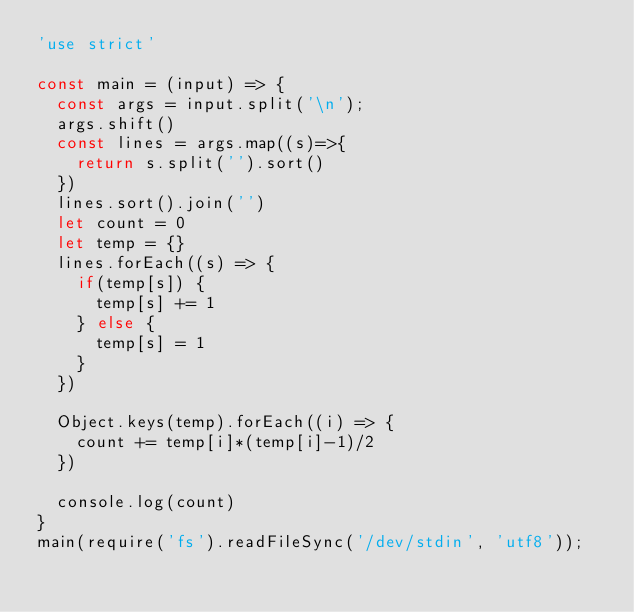Convert code to text. <code><loc_0><loc_0><loc_500><loc_500><_JavaScript_>'use strict'

const main = (input) => {
  const args = input.split('\n');
  args.shift()
  const lines = args.map((s)=>{
    return s.split('').sort()
  })
  lines.sort().join('')
  let count = 0
  let temp = {}
  lines.forEach((s) => {
    if(temp[s]) {
      temp[s] += 1
    } else {
      temp[s] = 1
    }
  })

  Object.keys(temp).forEach((i) => {
    count += temp[i]*(temp[i]-1)/2
  })

  console.log(count)
}
main(require('fs').readFileSync('/dev/stdin', 'utf8'));</code> 